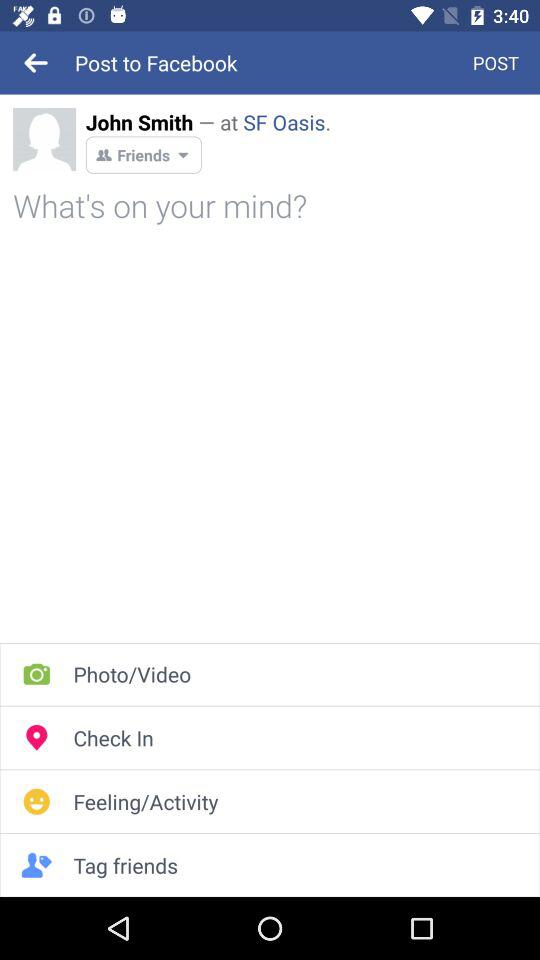This post was posted on which social site?
When the provided information is insufficient, respond with <no answer>. <no answer> 